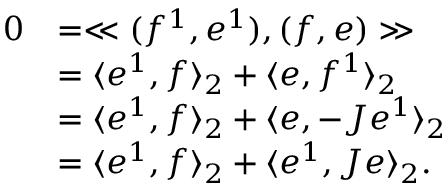Convert formula to latex. <formula><loc_0><loc_0><loc_500><loc_500>\begin{array} { r l } { 0 } & { = \ll ( f ^ { 1 } , e ^ { 1 } ) , ( f , e ) \gg } \\ & { = \langle e ^ { 1 } , f \rangle _ { 2 } + \langle e , f ^ { 1 } \rangle _ { 2 } } \\ & { = \langle e ^ { 1 } , f \rangle _ { 2 } + \langle e , - J e ^ { 1 } \rangle _ { 2 } } \\ & { = \langle e ^ { 1 } , f \rangle _ { 2 } + \langle e ^ { 1 } , J e \rangle _ { 2 } . } \end{array}</formula> 